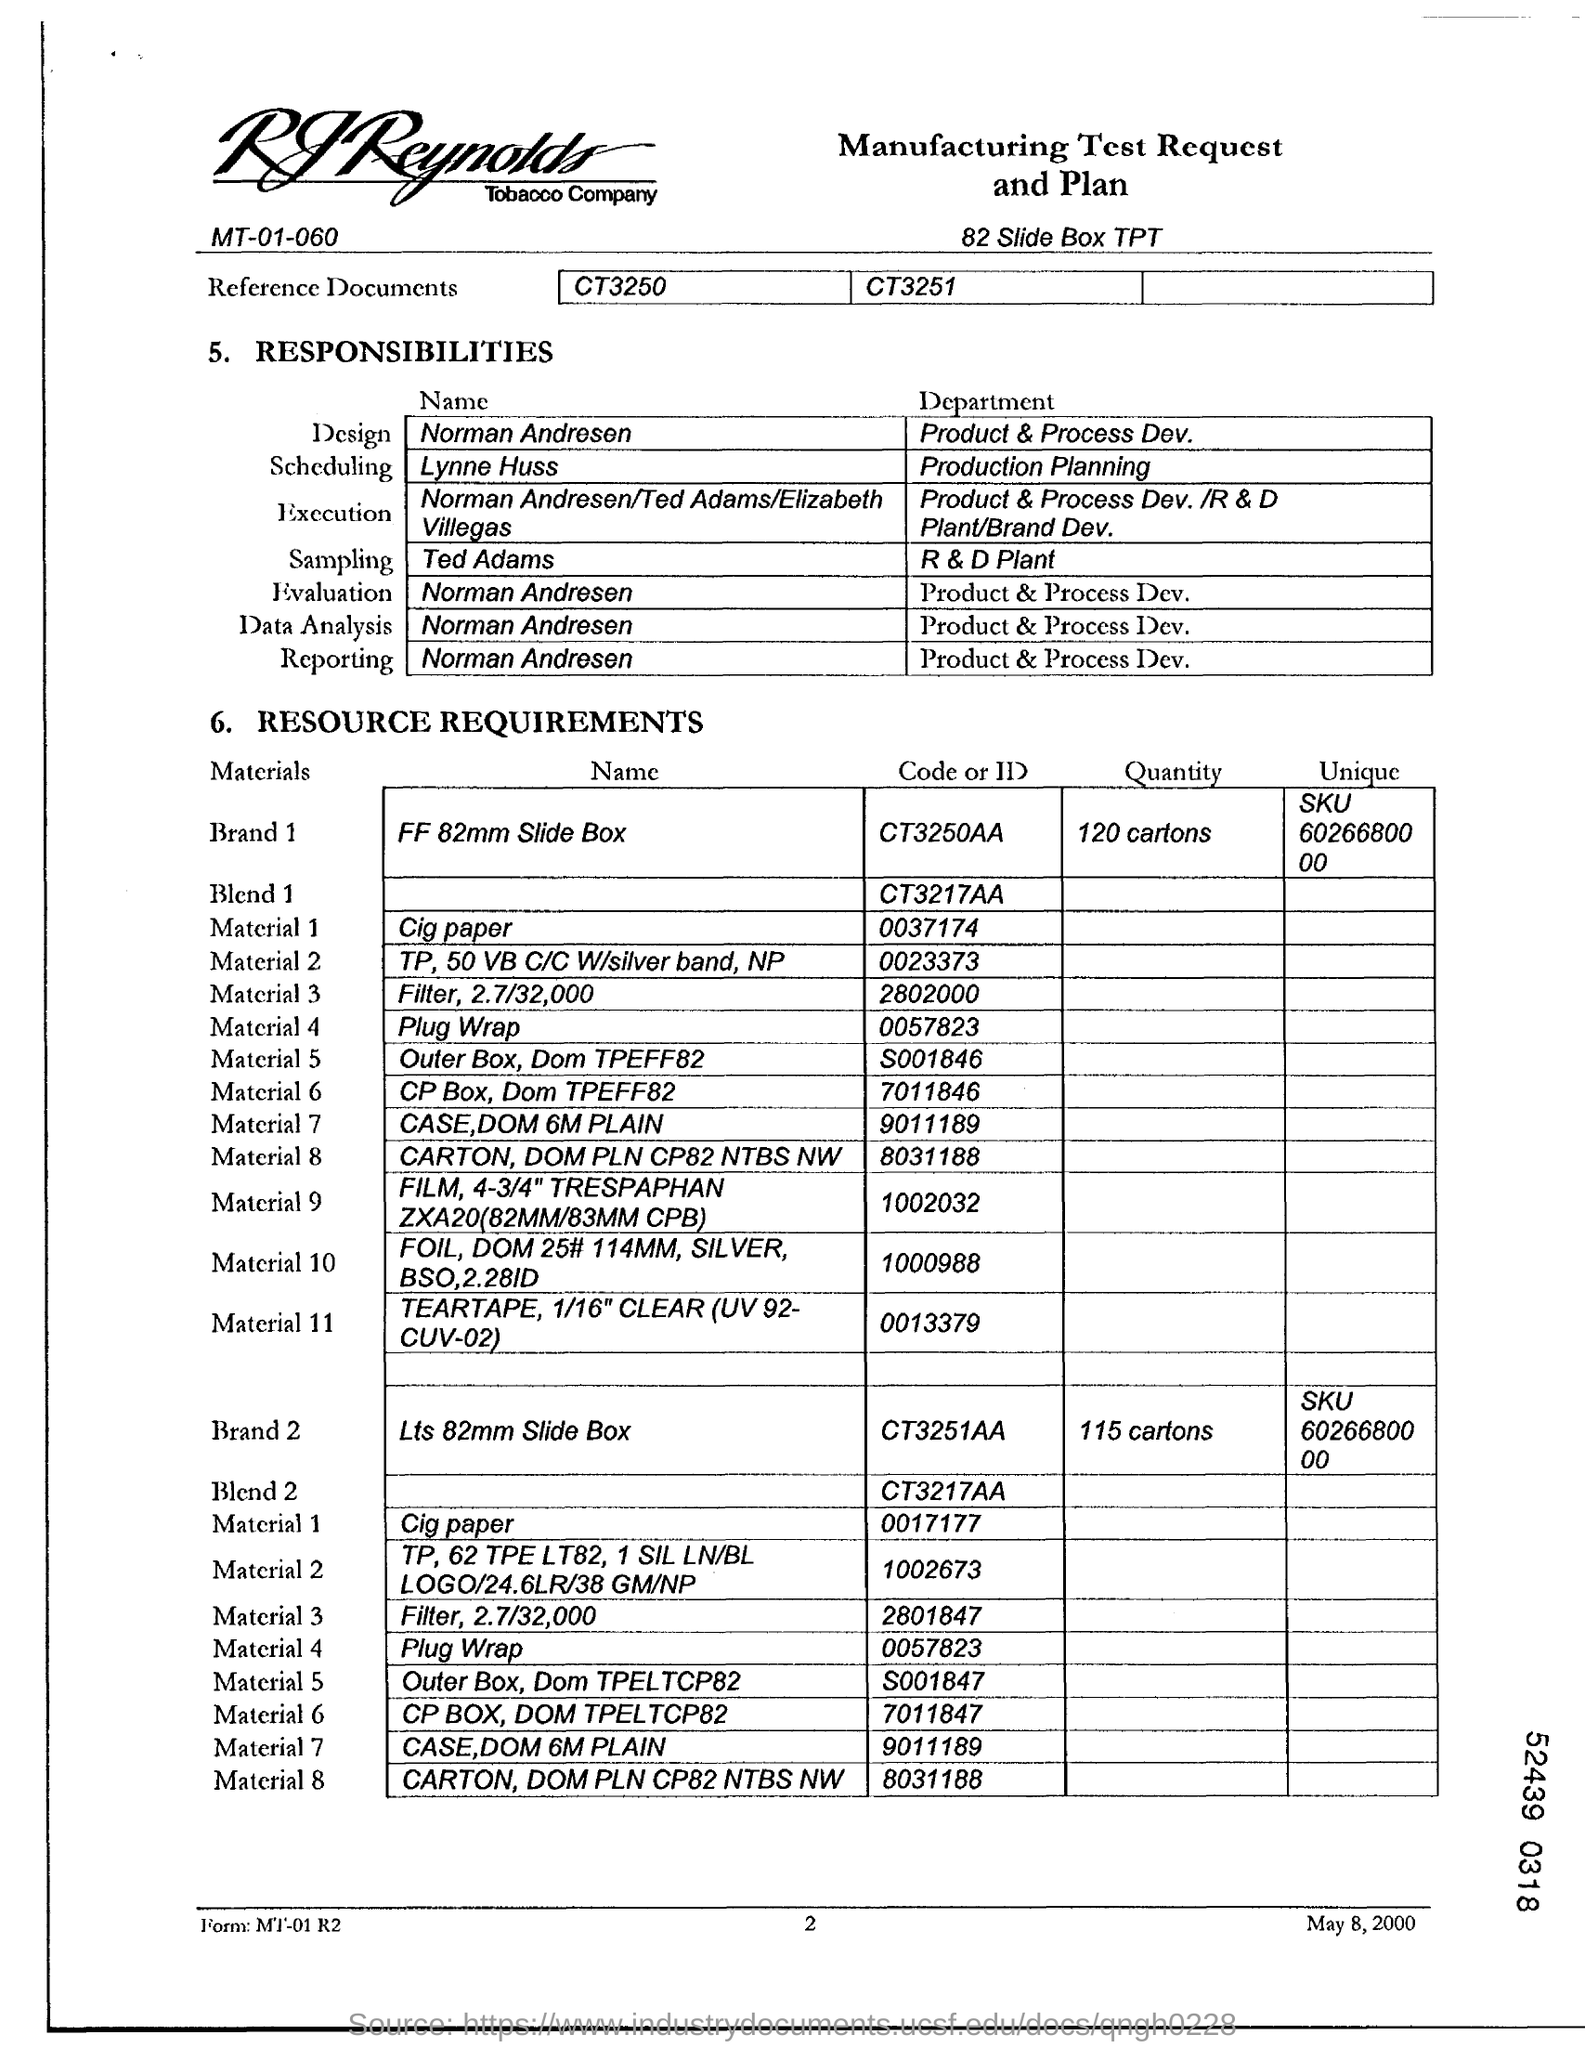Indicate a few pertinent items in this graphic. The date on the document is May 8, 2000. Norman Andresen works in the department of Product and Process Development. Ted Adams works in the R&D Plant department. Ted Adams works in the R&D Plant department. 